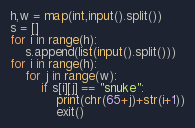Convert code to text. <code><loc_0><loc_0><loc_500><loc_500><_Python_>h,w = map(int,input().split())
s = []
for i in range(h):
    s.append(list(input().split()))
for i in range(h):
    for j in range(w):
        if s[i][j] == "snuke":
            print(chr(65+j)+str(i+1))
            exit()</code> 